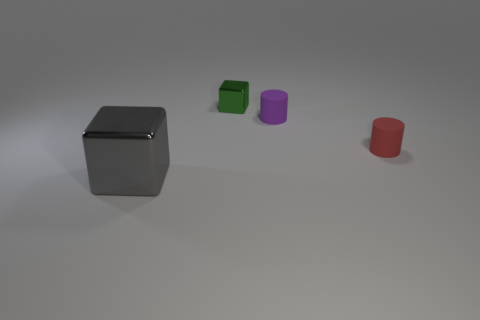There is a large metallic block; does it have the same color as the metal cube behind the big gray metal thing? The large metallic block in front has a reflective surface that appears to be a different color under current lighting conditions compared to the smaller metal cube behind it. The cube behind reflects a greenish hue indicating its surface is interacting with the surroundings differently. 